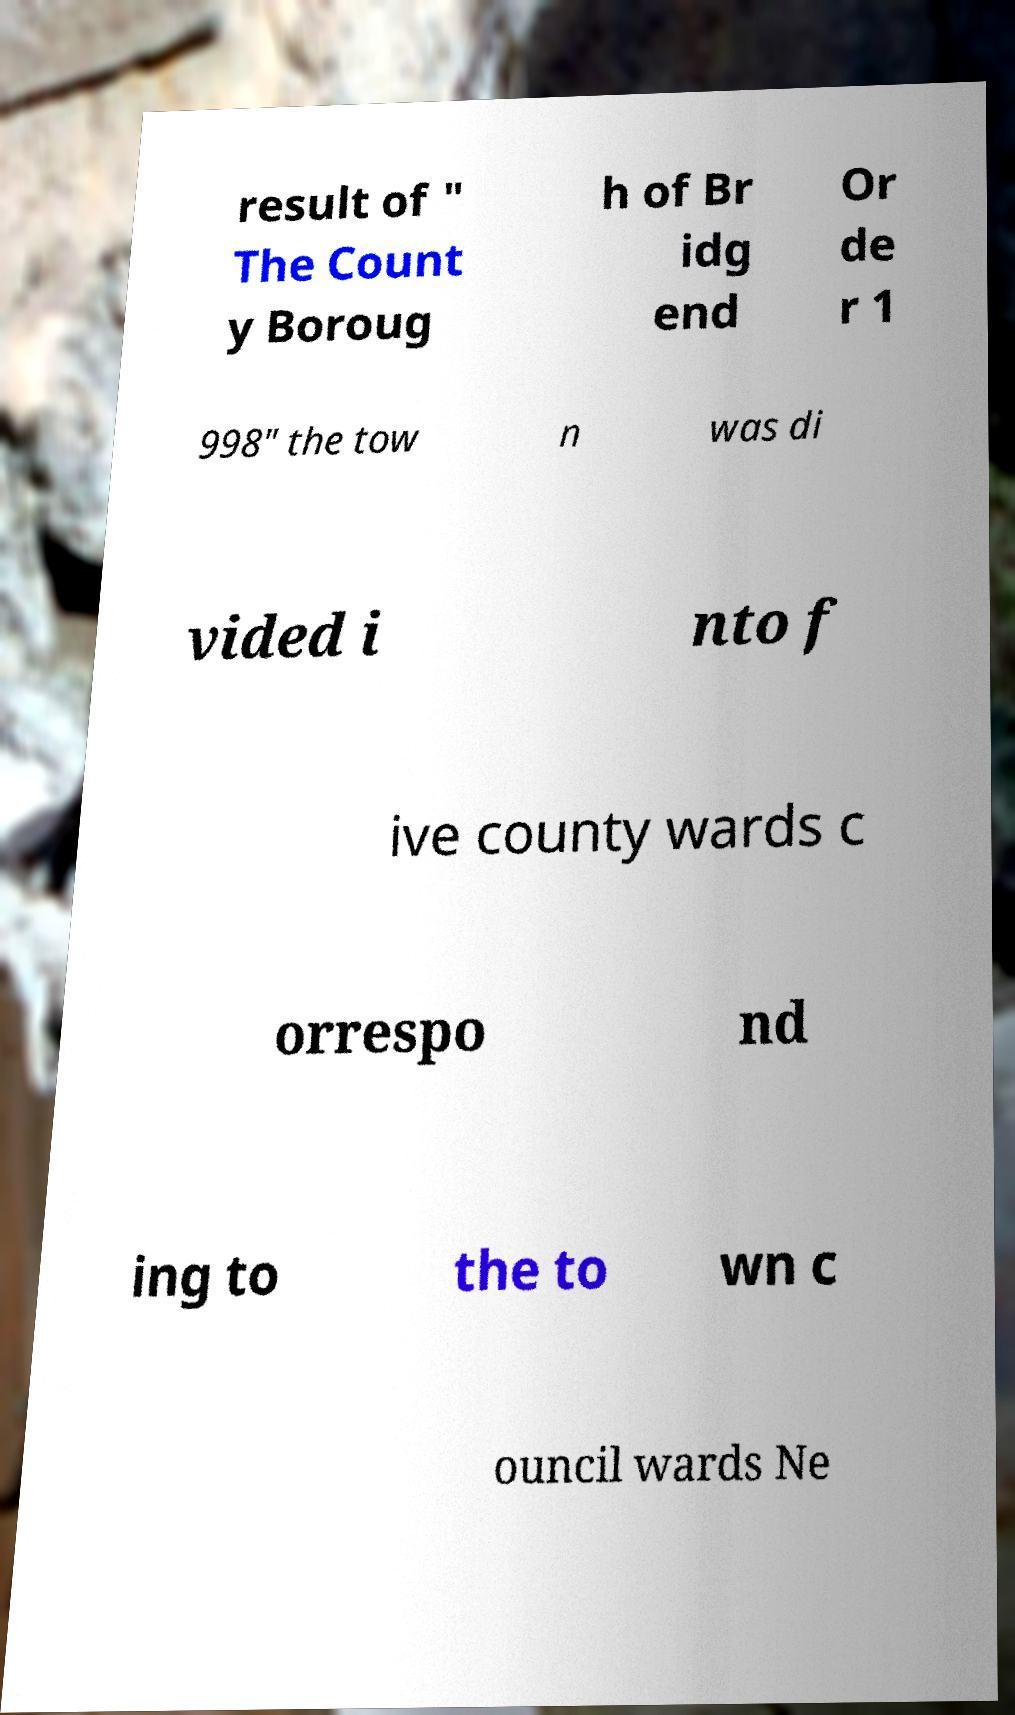I need the written content from this picture converted into text. Can you do that? result of " The Count y Boroug h of Br idg end Or de r 1 998" the tow n was di vided i nto f ive county wards c orrespo nd ing to the to wn c ouncil wards Ne 